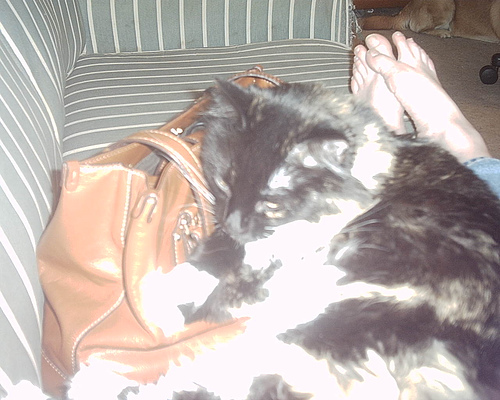Is the cat completely visible in the image? No, the cat is not completely visible. It is partially covered by the bright lighting, making it difficult to see some details of the cat clearly. 